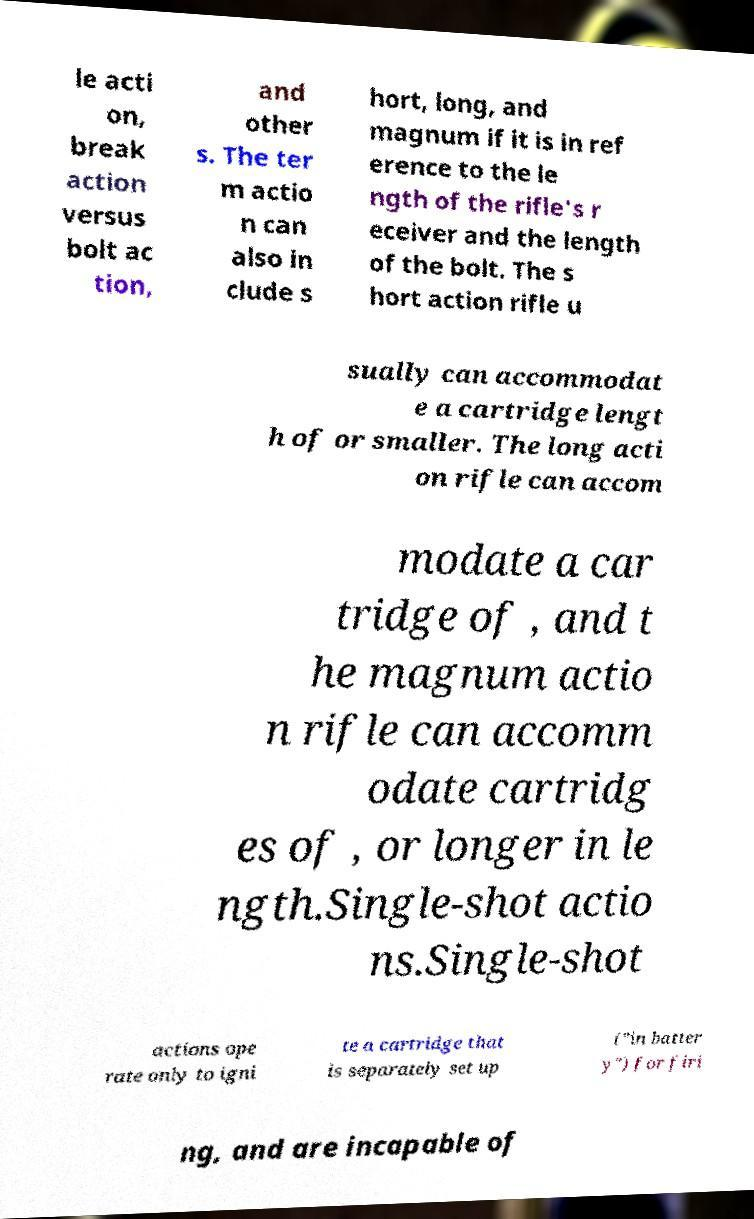For documentation purposes, I need the text within this image transcribed. Could you provide that? le acti on, break action versus bolt ac tion, and other s. The ter m actio n can also in clude s hort, long, and magnum if it is in ref erence to the le ngth of the rifle's r eceiver and the length of the bolt. The s hort action rifle u sually can accommodat e a cartridge lengt h of or smaller. The long acti on rifle can accom modate a car tridge of , and t he magnum actio n rifle can accomm odate cartridg es of , or longer in le ngth.Single-shot actio ns.Single-shot actions ope rate only to igni te a cartridge that is separately set up ("in batter y") for firi ng, and are incapable of 